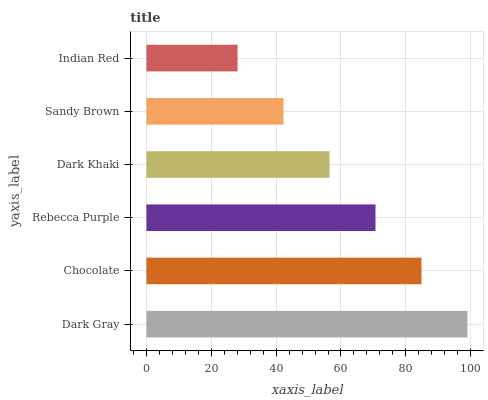Is Indian Red the minimum?
Answer yes or no. Yes. Is Dark Gray the maximum?
Answer yes or no. Yes. Is Chocolate the minimum?
Answer yes or no. No. Is Chocolate the maximum?
Answer yes or no. No. Is Dark Gray greater than Chocolate?
Answer yes or no. Yes. Is Chocolate less than Dark Gray?
Answer yes or no. Yes. Is Chocolate greater than Dark Gray?
Answer yes or no. No. Is Dark Gray less than Chocolate?
Answer yes or no. No. Is Rebecca Purple the high median?
Answer yes or no. Yes. Is Dark Khaki the low median?
Answer yes or no. Yes. Is Indian Red the high median?
Answer yes or no. No. Is Chocolate the low median?
Answer yes or no. No. 